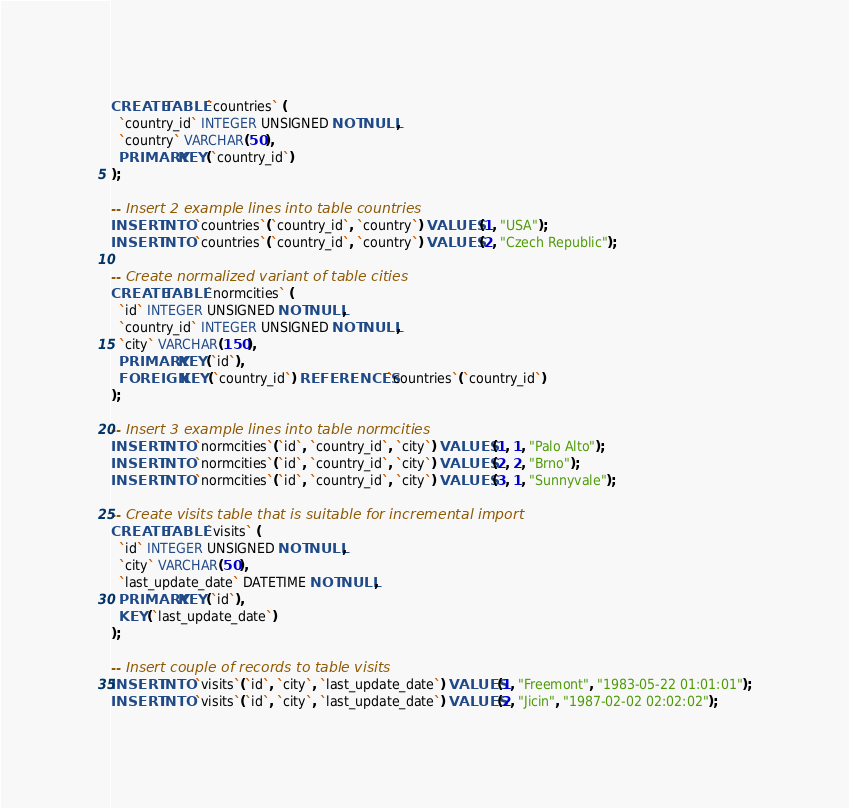<code> <loc_0><loc_0><loc_500><loc_500><_SQL_>CREATE TABLE `countries` (
  `country_id` INTEGER UNSIGNED NOT NULL,
  `country` VARCHAR(50),
  PRIMARY KEY (`country_id`)
);

-- Insert 2 example lines into table countries
INSERT INTO `countries`(`country_id`, `country`) VALUES (1, "USA");
INSERT INTO `countries`(`country_id`, `country`) VALUES (2, "Czech Republic");

-- Create normalized variant of table cities
CREATE TABLE `normcities` (
  `id` INTEGER UNSIGNED NOT NULL,
  `country_id` INTEGER UNSIGNED NOT NULL,
  `city` VARCHAR(150),
  PRIMARY KEY (`id`),
  FOREIGN KEY (`country_id`) REFERENCES `countries`(`country_id`)
);

-- Insert 3 example lines into table normcities
INSERT INTO `normcities`(`id`, `country_id`, `city`) VALUES (1, 1, "Palo Alto");
INSERT INTO `normcities`(`id`, `country_id`, `city`) VALUES (2, 2, "Brno");
INSERT INTO `normcities`(`id`, `country_id`, `city`) VALUES (3, 1, "Sunnyvale");

-- Create visits table that is suitable for incremental import
CREATE TABLE `visits` (
  `id` INTEGER UNSIGNED NOT NULL,
  `city` VARCHAR(50),
  `last_update_date` DATETIME NOT NULL,
  PRIMARY KEY (`id`),
  KEY (`last_update_date`)
);

-- Insert couple of records to table visits
INSERT INTO `visits`(`id`, `city`, `last_update_date`) VALUES(1, "Freemont", "1983-05-22 01:01:01");
INSERT INTO `visits`(`id`, `city`, `last_update_date`) VALUES(2, "Jicin", "1987-02-02 02:02:02");
</code> 